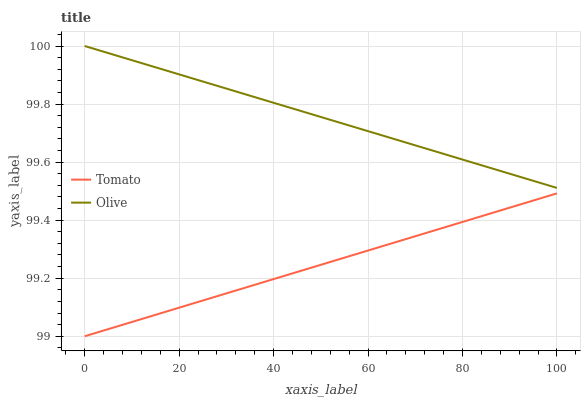Does Tomato have the minimum area under the curve?
Answer yes or no. Yes. Does Olive have the maximum area under the curve?
Answer yes or no. Yes. Does Olive have the minimum area under the curve?
Answer yes or no. No. Is Tomato the smoothest?
Answer yes or no. Yes. Is Olive the roughest?
Answer yes or no. Yes. Is Olive the smoothest?
Answer yes or no. No. Does Olive have the lowest value?
Answer yes or no. No. Does Olive have the highest value?
Answer yes or no. Yes. Is Tomato less than Olive?
Answer yes or no. Yes. Is Olive greater than Tomato?
Answer yes or no. Yes. Does Tomato intersect Olive?
Answer yes or no. No. 